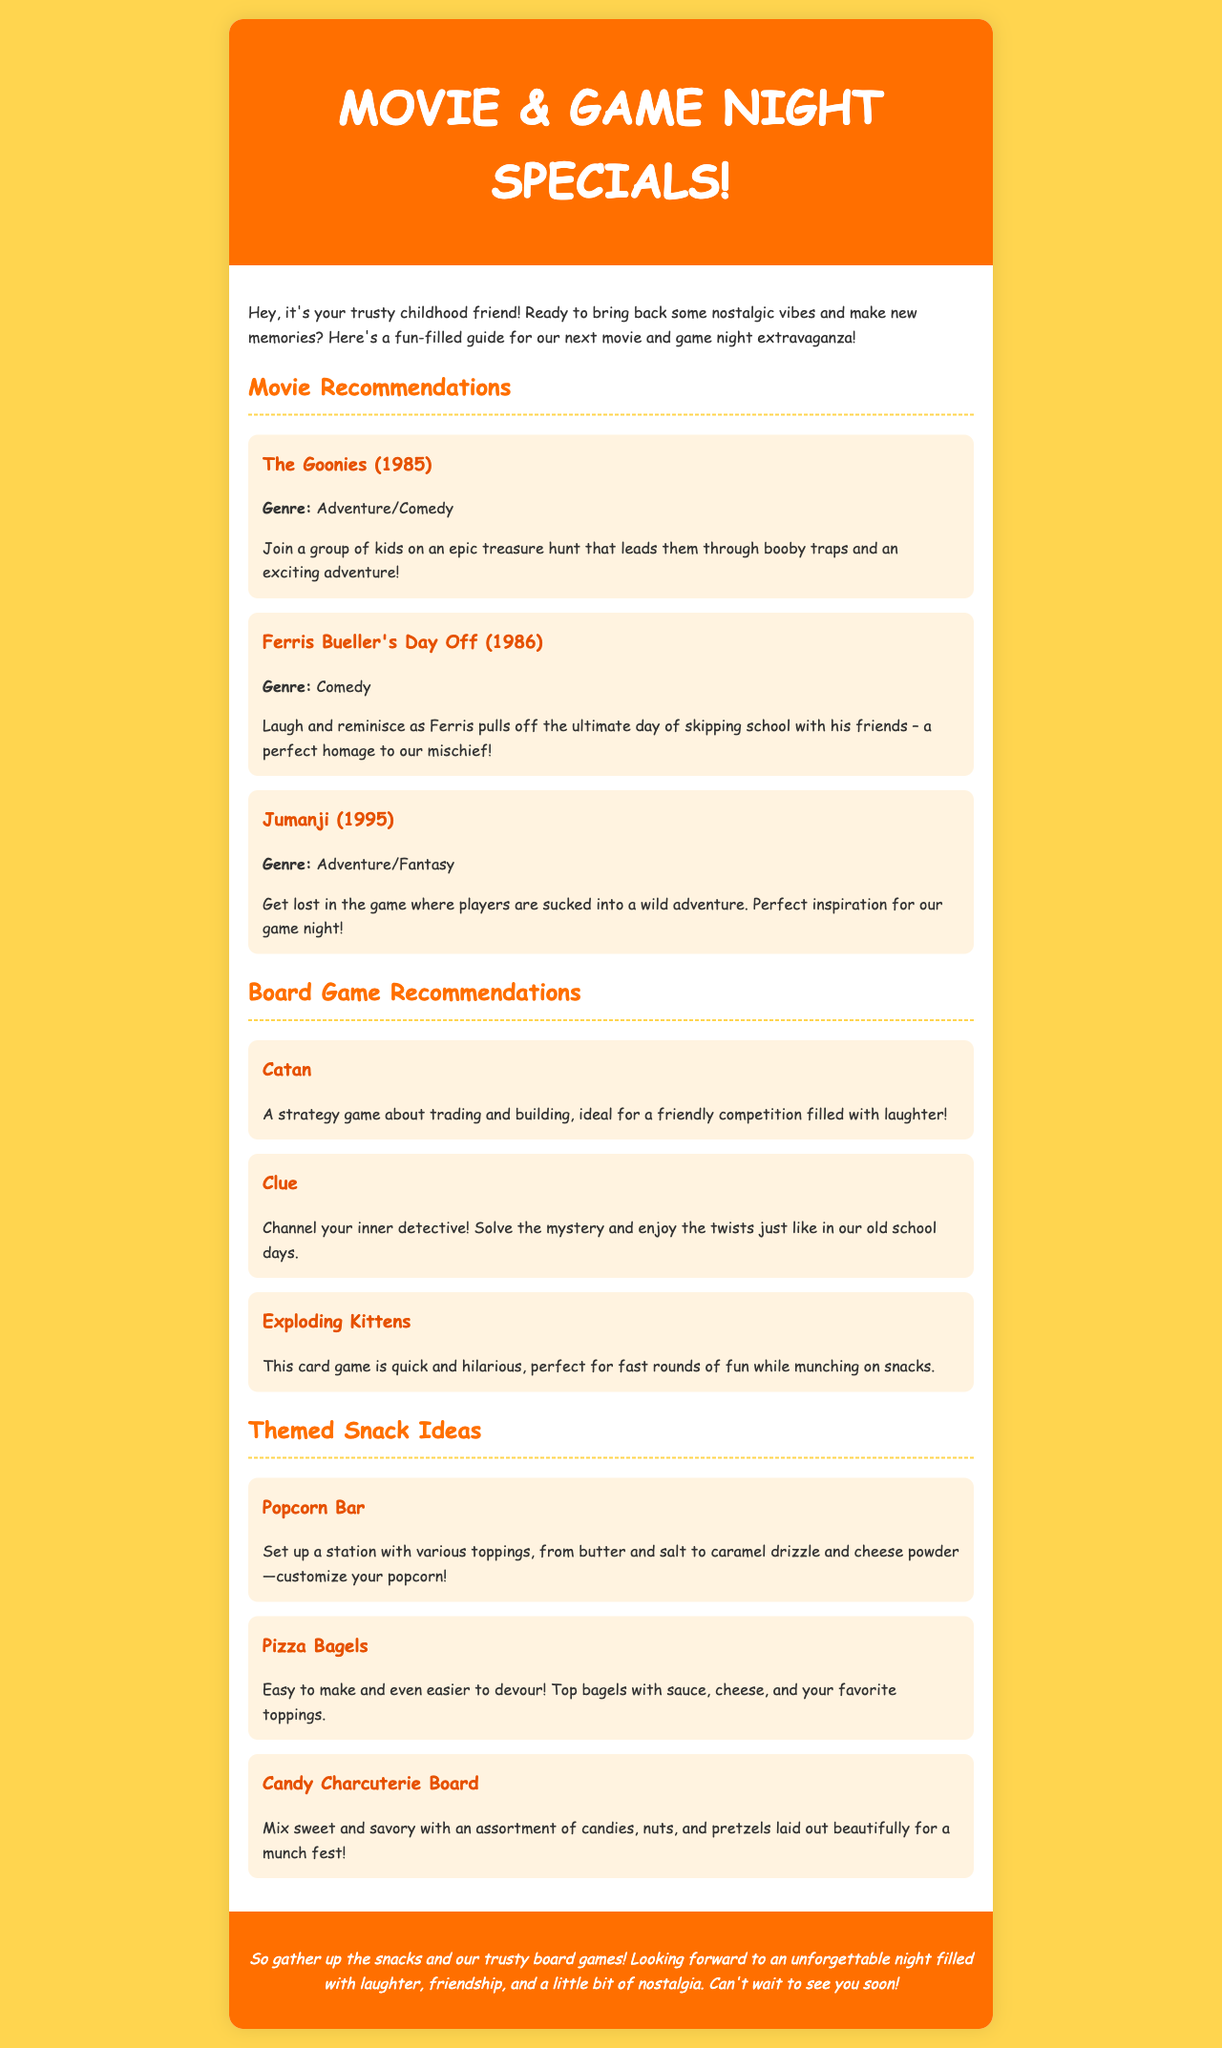What are the three movie recommendations? The document lists three movies under Movie Recommendations: The Goonies, Ferris Bueller's Day Off, and Jumanji.
Answer: The Goonies, Ferris Bueller's Day Off, Jumanji What is the genre of Ferris Bueller's Day Off? The movie’s genre is specified under its title, which is Comedy.
Answer: Comedy How many board games are recommended in the document? There are three board games listed under Board Game Recommendations: Catan, Clue, and Exploding Kittens.
Answer: Three Which snack includes a customization option? The document mentions a Popcorn Bar where various toppings can be added.
Answer: Popcorn Bar What key theme binds the movie recommendations together? The movies are centered around fun adventures and nostalgia, especially highlighting friendship and childhood memories.
Answer: Nostalgia 